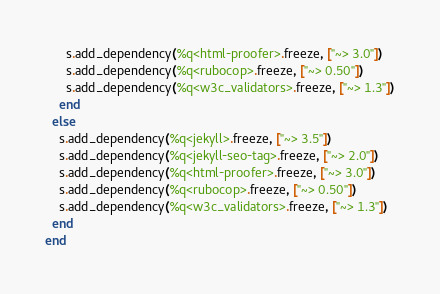<code> <loc_0><loc_0><loc_500><loc_500><_Ruby_>      s.add_dependency(%q<html-proofer>.freeze, ["~> 3.0"])
      s.add_dependency(%q<rubocop>.freeze, ["~> 0.50"])
      s.add_dependency(%q<w3c_validators>.freeze, ["~> 1.3"])
    end
  else
    s.add_dependency(%q<jekyll>.freeze, ["~> 3.5"])
    s.add_dependency(%q<jekyll-seo-tag>.freeze, ["~> 2.0"])
    s.add_dependency(%q<html-proofer>.freeze, ["~> 3.0"])
    s.add_dependency(%q<rubocop>.freeze, ["~> 0.50"])
    s.add_dependency(%q<w3c_validators>.freeze, ["~> 1.3"])
  end
end
</code> 